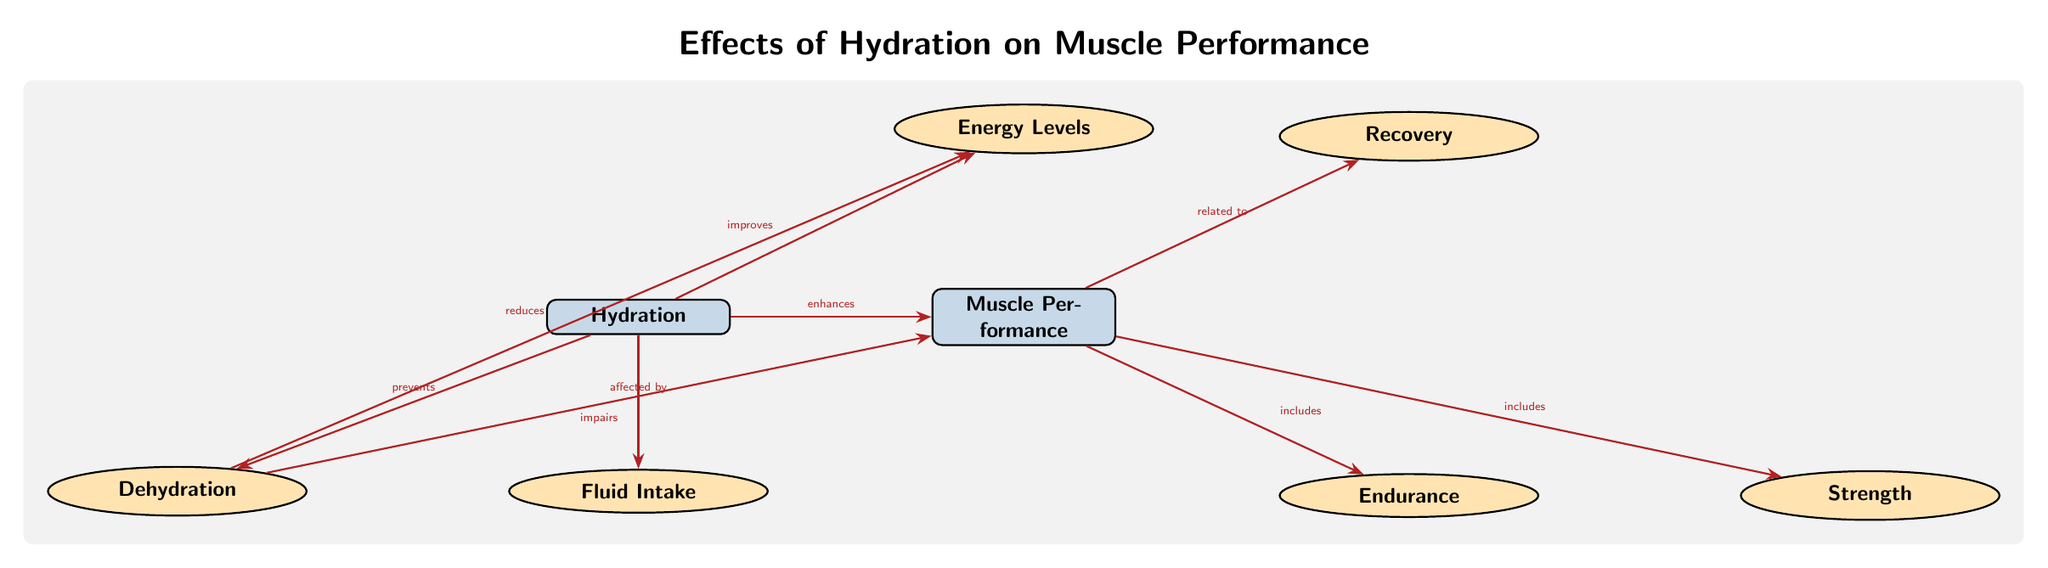What are the two main components linked in the diagram? The diagram highlights hydration and muscle performance as the two primary nodes. They are positioned at the top of the diagram, clearly indicating their relationship.
Answer: Hydration, Muscle Performance What does dehydration do to muscle performance? The diagram explicitly states that dehydration impairs muscle performance, identified by the label on the edge connecting dehydration and muscle performance.
Answer: Impairs What are the three aspects included under muscle performance? By analyzing the edges connecting to the muscle node, we note that endurance, strength, and recovery are mentioned. These are the secondary nodes linked to muscle performance.
Answer: Endurance, Strength, Recovery How does hydration affect energy levels? According to the diagram, hydration improves energy levels, indicated by the edge connecting hydration to energy levels with a labeled relationship stating "improves."
Answer: Improves What is one effect of hydration on muscle performance? The diagram states that hydration enhances muscle performance, shown by an arrow pointing from hydration to muscle performance with that label.
Answer: Enhances What relationship exists between fluid intake and hydration? The diagram shows that hydration is affected by fluid intake, which is indicated by the edge linking these two components.
Answer: Affected by Which factor is shown to reduce energy levels? The label on the edge from dehydration to energy clearly states that it reduces energy levels, establishing this harmful relationship.
Answer: Reduces What can be inferred about the importance of hydration from this diagram? The diagram presents hydration as a crucial factor that prevents dehydration and enhances muscle performance, indicating its vital role. The numerous connections underscore its significance for overall muscle function.
Answer: Vital role 